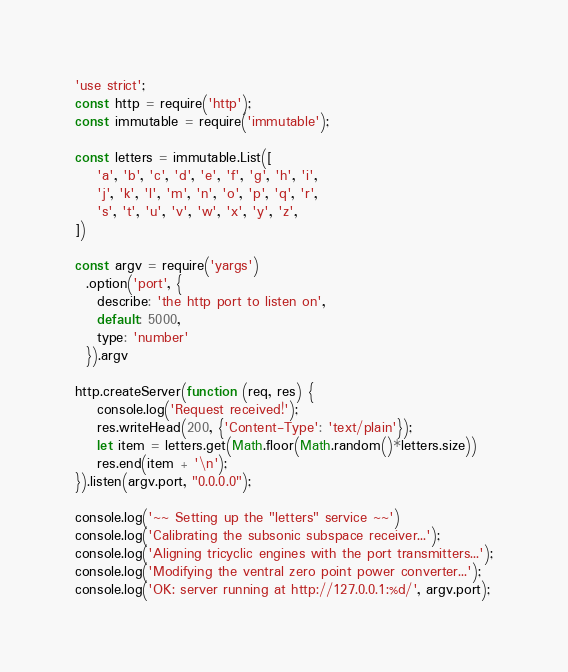Convert code to text. <code><loc_0><loc_0><loc_500><loc_500><_JavaScript_>'use strict';
const http = require('http');
const immutable = require('immutable');

const letters = immutable.List([
    'a', 'b', 'c', 'd', 'e', 'f', 'g', 'h', 'i',
    'j', 'k', 'l', 'm', 'n', 'o', 'p', 'q', 'r',
    's', 't', 'u', 'v', 'w', 'x', 'y', 'z',
])

const argv = require('yargs')
  .option('port', {
    describe: 'the http port to listen on',
    default: 5000,
    type: 'number'
  }).argv

http.createServer(function (req, res) {
    console.log('Request received!');
    res.writeHead(200, {'Content-Type': 'text/plain'});
    let item = letters.get(Math.floor(Math.random()*letters.size))
    res.end(item + '\n');
}).listen(argv.port, "0.0.0.0");

console.log('~~ Setting up the "letters" service ~~')
console.log('Calibrating the subsonic subspace receiver...');
console.log('Aligning tricyclic engines with the port transmitters...');
console.log('Modifying the ventral zero point power converter...');
console.log('OK: server running at http://127.0.0.1:%d/', argv.port);
</code> 